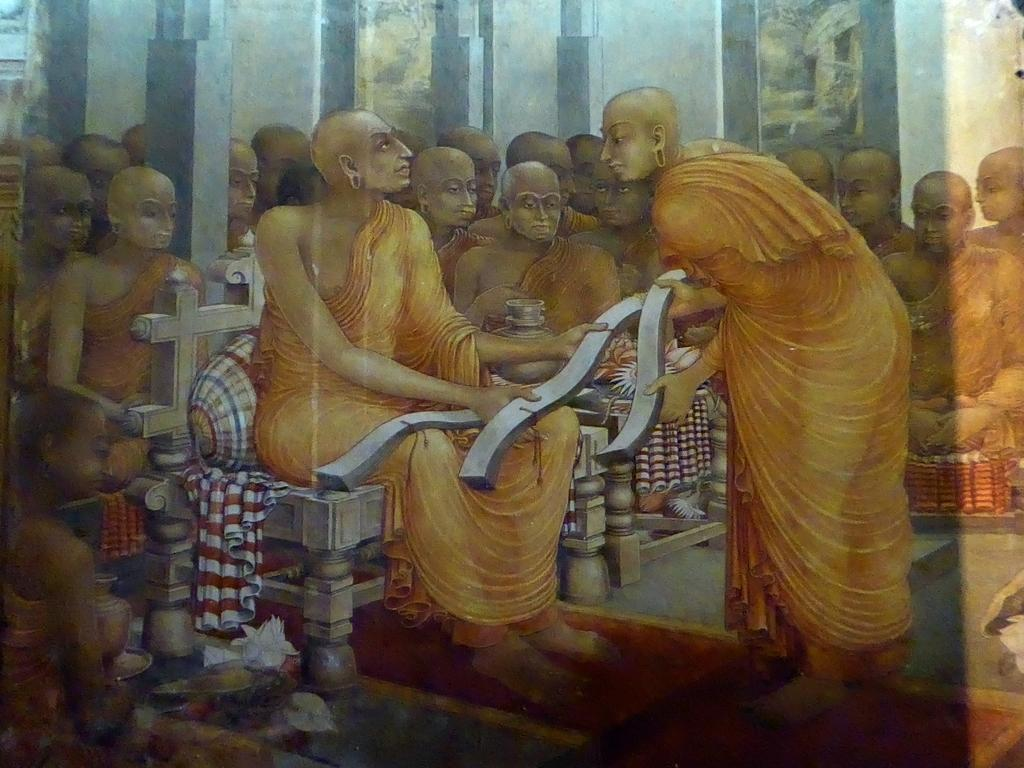What is the main subject of the painting in the image? The main subject of the painting is a temple. What can be seen inside the temple in the image? There are many monks sitting inside the temple. Can you describe the monk sitting in the front? The monk on the chair is holding scripts. What type of metal is the middle of the temple made of in the image? The image is a painting, and there is no mention of the temple's construction material, so it cannot be determined from the image. Can you see any ducks swimming in the temple in the image? There are no ducks present in the image; it features a temple with monks inside. 